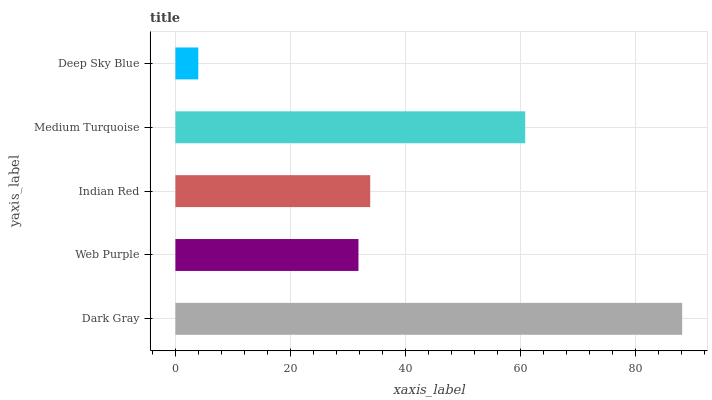Is Deep Sky Blue the minimum?
Answer yes or no. Yes. Is Dark Gray the maximum?
Answer yes or no. Yes. Is Web Purple the minimum?
Answer yes or no. No. Is Web Purple the maximum?
Answer yes or no. No. Is Dark Gray greater than Web Purple?
Answer yes or no. Yes. Is Web Purple less than Dark Gray?
Answer yes or no. Yes. Is Web Purple greater than Dark Gray?
Answer yes or no. No. Is Dark Gray less than Web Purple?
Answer yes or no. No. Is Indian Red the high median?
Answer yes or no. Yes. Is Indian Red the low median?
Answer yes or no. Yes. Is Deep Sky Blue the high median?
Answer yes or no. No. Is Web Purple the low median?
Answer yes or no. No. 